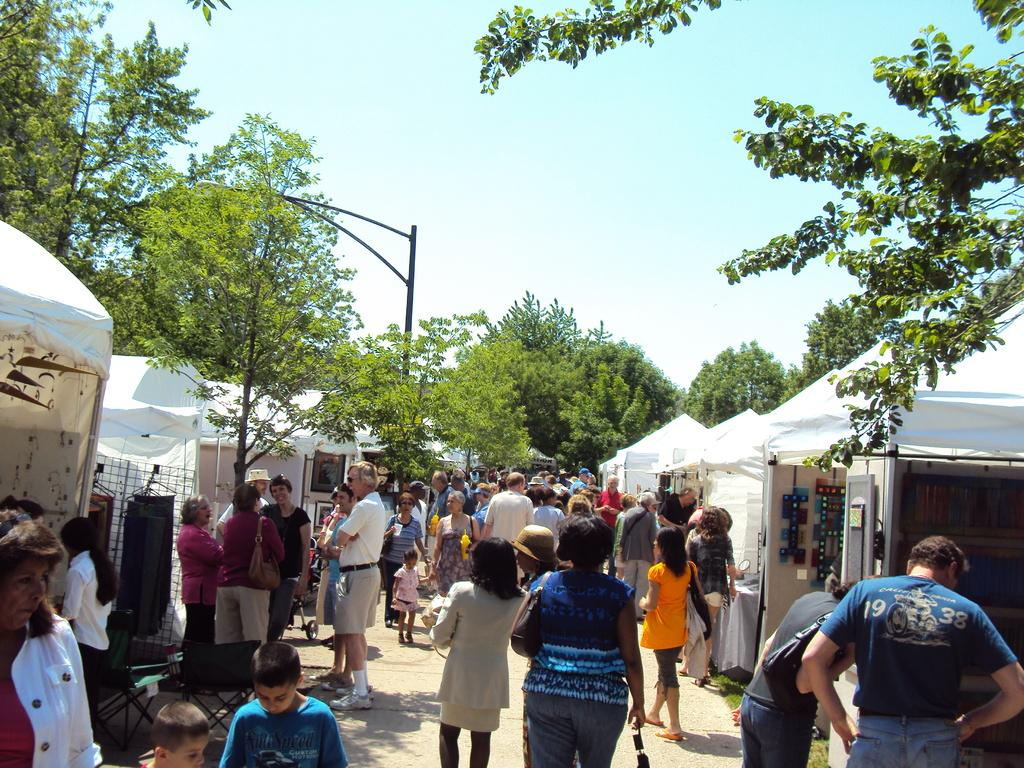What are the people in the image doing? The people in the image are walking on the road and standing in front of stalls. What can be seen in the background of the image? There are trees and the sky visible in the background of the image. What type of sugar is being used to cook on the stove in the image? There is no stove or sugar present in the image; it features people walking on the road and standing in front of stalls. Can you see any frogs in the image? There are no frogs visible in the image. 